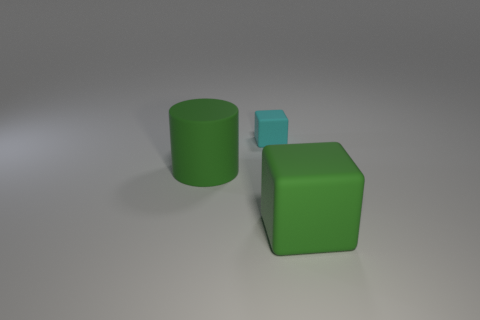Add 1 blue rubber blocks. How many objects exist? 4 Subtract all cylinders. How many objects are left? 2 Subtract 0 purple blocks. How many objects are left? 3 Subtract all big cyan matte cylinders. Subtract all matte things. How many objects are left? 0 Add 2 green matte cubes. How many green matte cubes are left? 3 Add 3 large cubes. How many large cubes exist? 4 